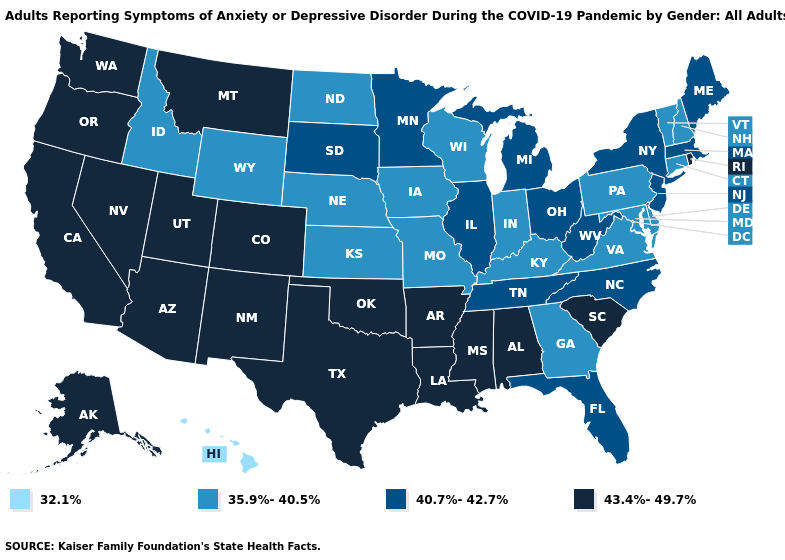What is the value of Delaware?
Quick response, please. 35.9%-40.5%. Name the states that have a value in the range 40.7%-42.7%?
Give a very brief answer. Florida, Illinois, Maine, Massachusetts, Michigan, Minnesota, New Jersey, New York, North Carolina, Ohio, South Dakota, Tennessee, West Virginia. Name the states that have a value in the range 40.7%-42.7%?
Write a very short answer. Florida, Illinois, Maine, Massachusetts, Michigan, Minnesota, New Jersey, New York, North Carolina, Ohio, South Dakota, Tennessee, West Virginia. Name the states that have a value in the range 35.9%-40.5%?
Write a very short answer. Connecticut, Delaware, Georgia, Idaho, Indiana, Iowa, Kansas, Kentucky, Maryland, Missouri, Nebraska, New Hampshire, North Dakota, Pennsylvania, Vermont, Virginia, Wisconsin, Wyoming. Does Louisiana have the highest value in the South?
Answer briefly. Yes. Among the states that border Idaho , does Wyoming have the lowest value?
Be succinct. Yes. What is the value of New Jersey?
Answer briefly. 40.7%-42.7%. What is the value of Tennessee?
Write a very short answer. 40.7%-42.7%. Name the states that have a value in the range 35.9%-40.5%?
Give a very brief answer. Connecticut, Delaware, Georgia, Idaho, Indiana, Iowa, Kansas, Kentucky, Maryland, Missouri, Nebraska, New Hampshire, North Dakota, Pennsylvania, Vermont, Virginia, Wisconsin, Wyoming. What is the value of Mississippi?
Be succinct. 43.4%-49.7%. Which states have the lowest value in the USA?
Be succinct. Hawaii. What is the highest value in the USA?
Answer briefly. 43.4%-49.7%. Name the states that have a value in the range 43.4%-49.7%?
Quick response, please. Alabama, Alaska, Arizona, Arkansas, California, Colorado, Louisiana, Mississippi, Montana, Nevada, New Mexico, Oklahoma, Oregon, Rhode Island, South Carolina, Texas, Utah, Washington. What is the value of Minnesota?
Answer briefly. 40.7%-42.7%. Does the map have missing data?
Give a very brief answer. No. 